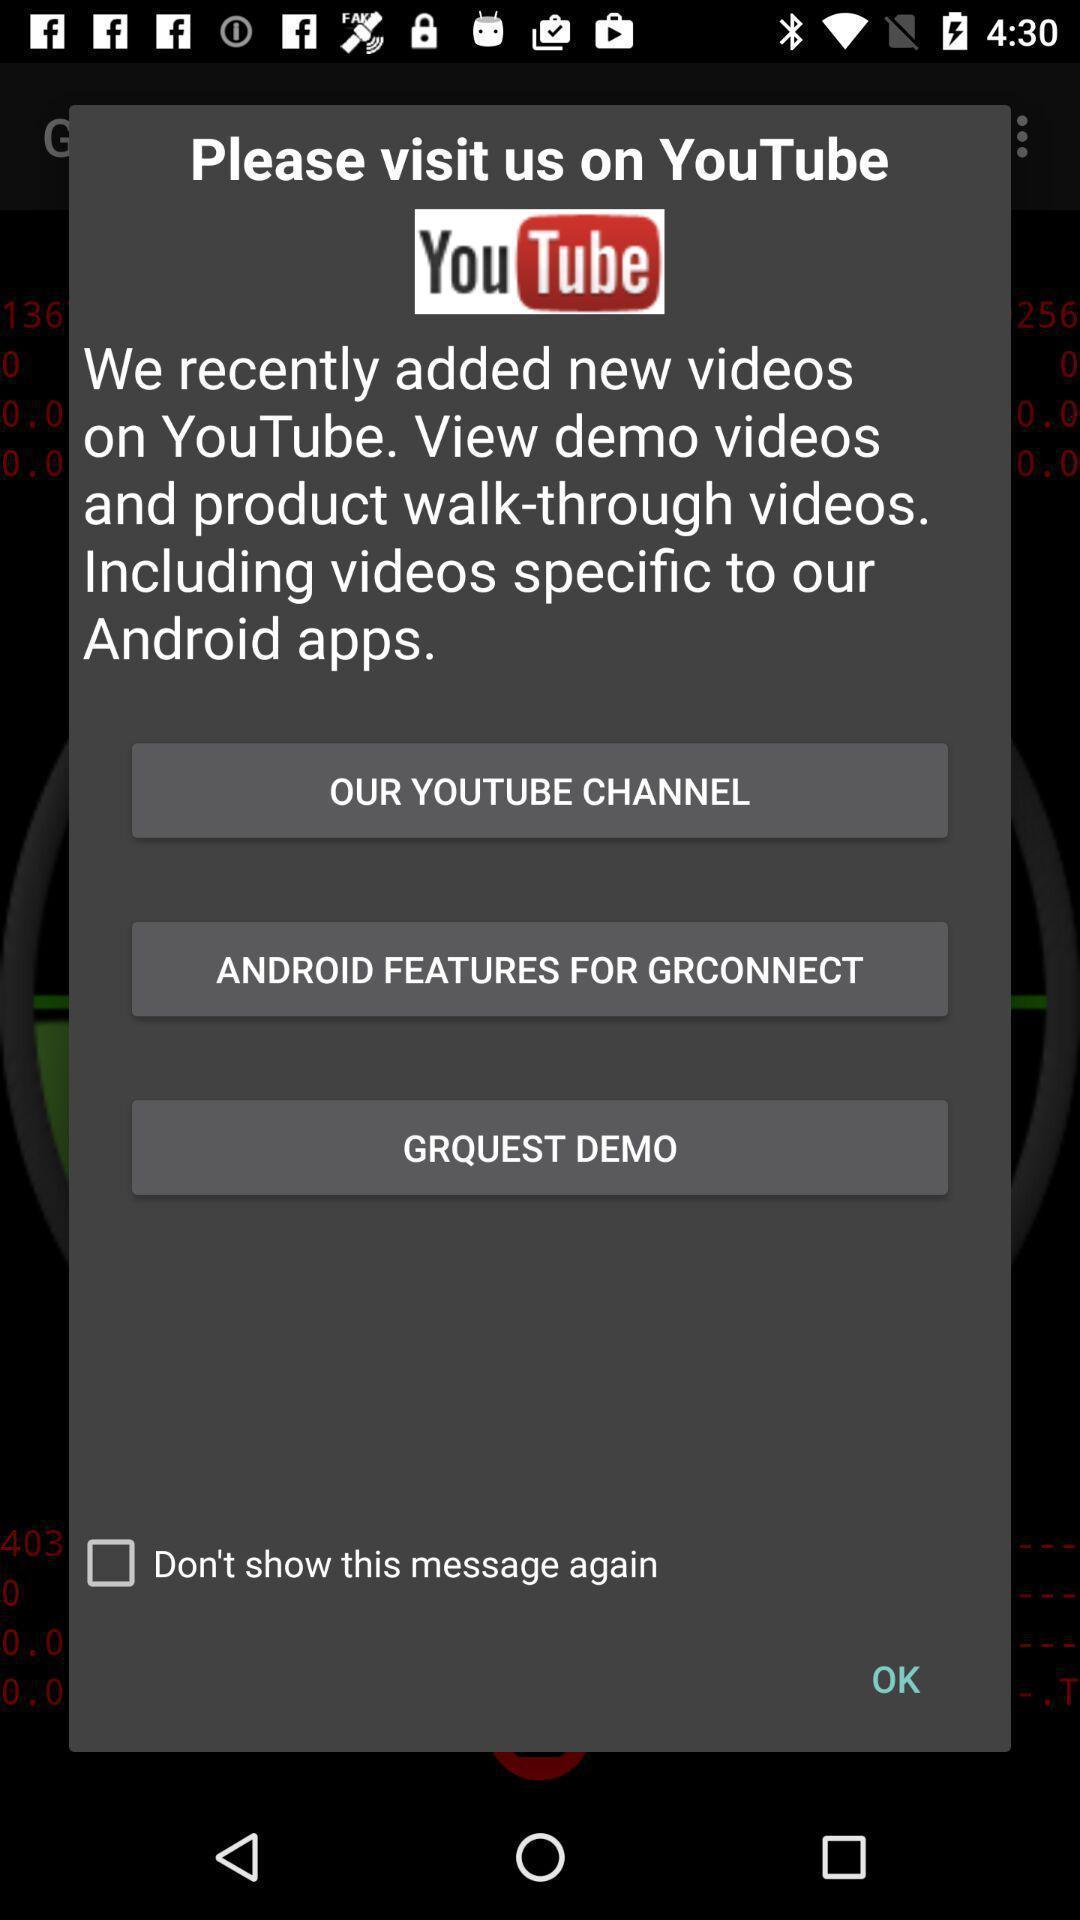Tell me what you see in this picture. Pop-up displaying for social app. 